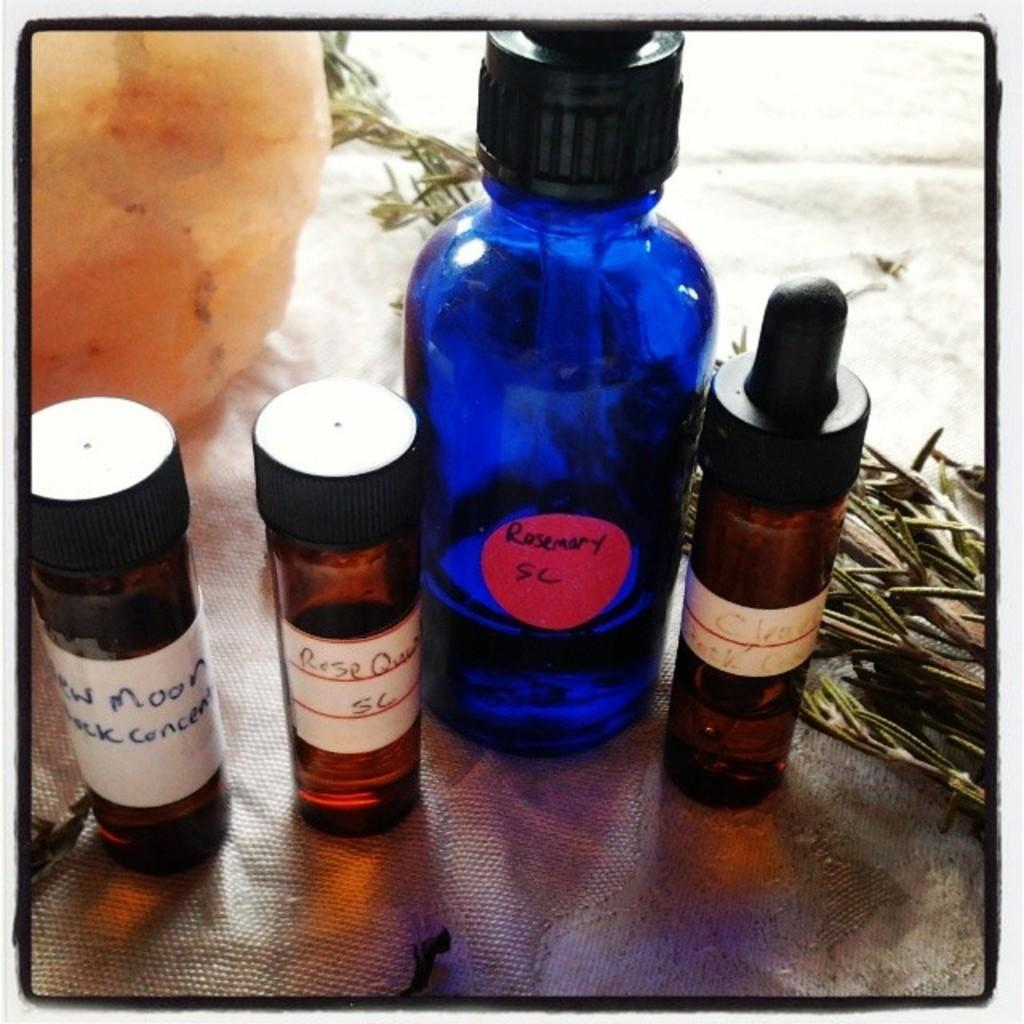<image>
Share a concise interpretation of the image provided. A group of four bottles, including a large blue bottle with the label Rosemary on it. 